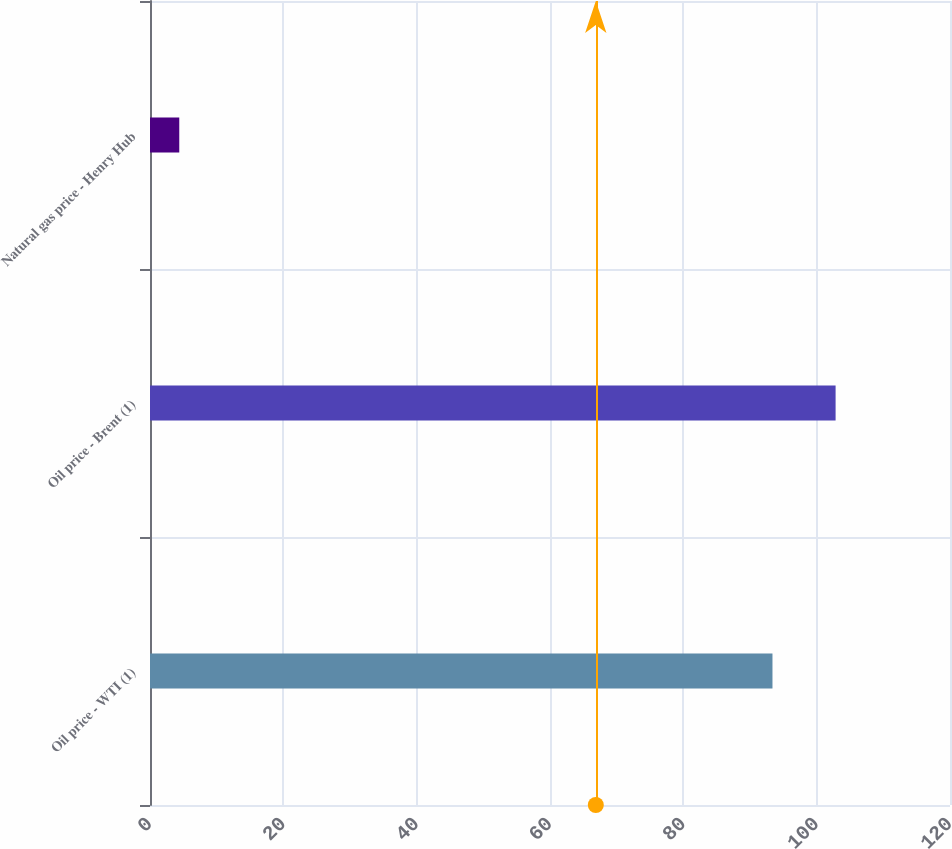Convert chart to OTSL. <chart><loc_0><loc_0><loc_500><loc_500><bar_chart><fcel>Oil price - WTI (1)<fcel>Oil price - Brent (1)<fcel>Natural gas price - Henry Hub<nl><fcel>93.37<fcel>102.84<fcel>4.39<nl></chart> 